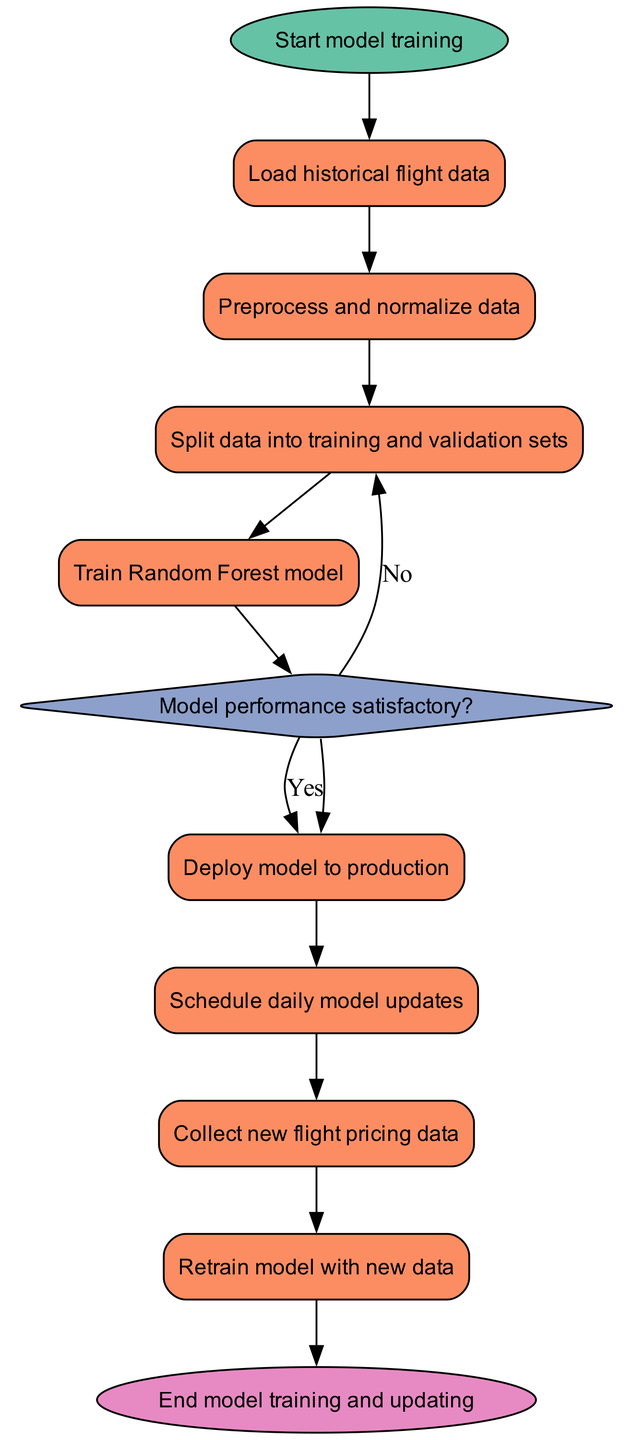what is the first action in the training process? The first action in the training process is represented in the "Start model training" element, which indicates the initiation of the process.
Answer: Start model training how many process nodes are there in the diagram? By counting the nodes of type "process" in the diagram, which are tasks that involve performing actions, we find there are five of them.
Answer: 5 what happens if the model performance is satisfactory? If the model performance is satisfactory, the flow proceeds to the next process where the model is deployed to production, indicating a successful outcome.
Answer: Deploy model to production what is the last process before ending the model training and updating? The last process before the flow reaches the end is the "Retrain model with new data," which indicates that the model is updated with new information prior to concluding the process.
Answer: Retrain model with new data what are the two possible outcomes when the model performance is assessed? Upon assessing model performance, the two outcomes are "satisfactory," leading to deployment, or "not satisfactory," which typically necessitates further improvements or processing.
Answer: Satisfactory, Not satisfactory how often are model updates scheduled according to the diagram? The schedule for model updates is indicated as "daily," which implies a regular frequency to ensure the model remains up-to-date with pricing data.
Answer: Daily which step involves handling new flight pricing data? The step that deals with handling new flight pricing data is "Collect new flight pricing data," which captures the ongoing information necessary for updating the model.
Answer: Collect new flight pricing data what shape represents the decision point in the flow? The decision point in the flow is represented by a diamond shape, which is standard for indicating a decision that leads to different pathways based on the outcome.
Answer: Diamond 